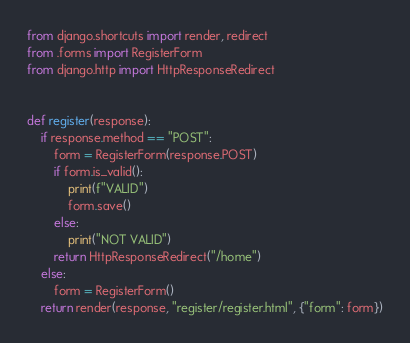Convert code to text. <code><loc_0><loc_0><loc_500><loc_500><_Python_>from django.shortcuts import render, redirect
from .forms import RegisterForm
from django.http import HttpResponseRedirect


def register(response):
    if response.method == "POST":
        form = RegisterForm(response.POST)
        if form.is_valid():
            print(f"VALID")
            form.save()
        else:
            print("NOT VALID")
        return HttpResponseRedirect("/home")
    else:
        form = RegisterForm()
    return render(response, "register/register.html", {"form": form})
</code> 